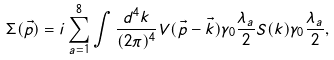<formula> <loc_0><loc_0><loc_500><loc_500>\Sigma ( \vec { p } ) = i \sum _ { a = 1 } ^ { 8 } \int \frac { d ^ { 4 } k } { ( 2 \pi ) ^ { 4 } } V ( { \vec { p } } - { \vec { k } } ) \gamma _ { 0 } \frac { \lambda _ { a } } 2 S ( k ) \gamma _ { 0 } \frac { \lambda _ { a } } 2 ,</formula> 